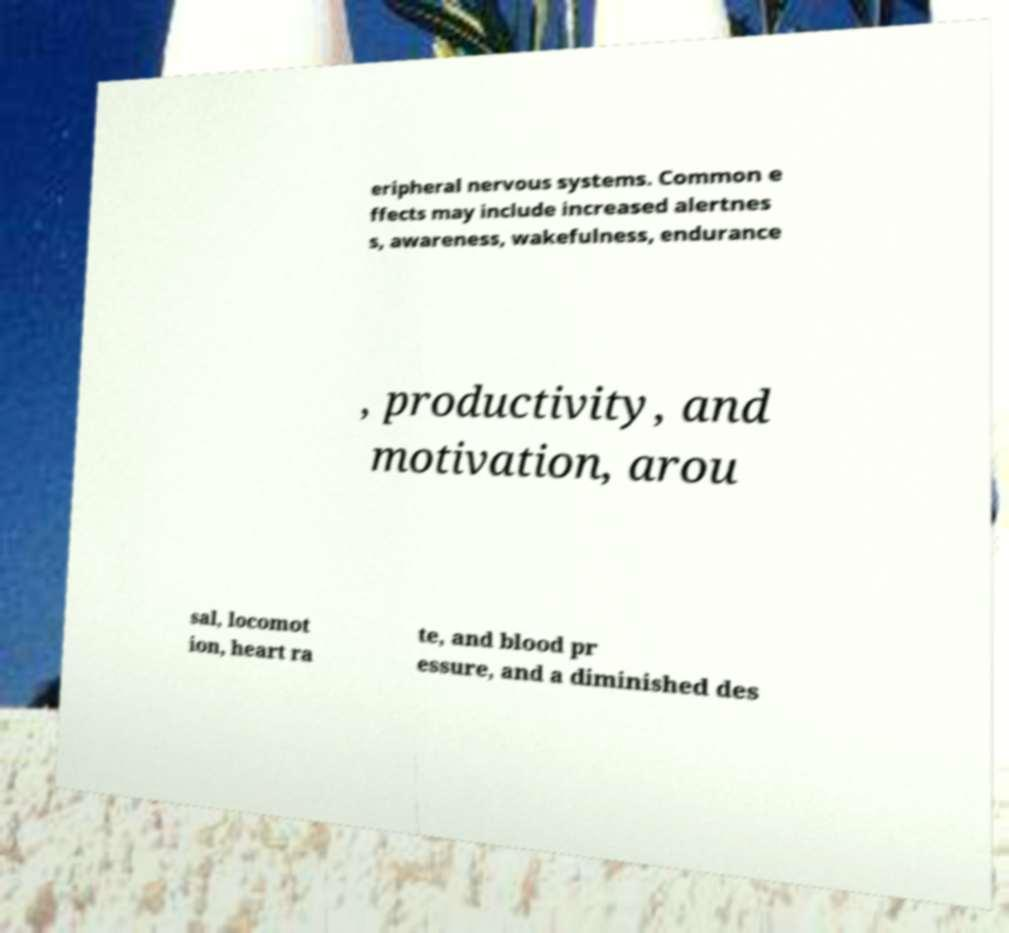Can you read and provide the text displayed in the image?This photo seems to have some interesting text. Can you extract and type it out for me? eripheral nervous systems. Common e ffects may include increased alertnes s, awareness, wakefulness, endurance , productivity, and motivation, arou sal, locomot ion, heart ra te, and blood pr essure, and a diminished des 